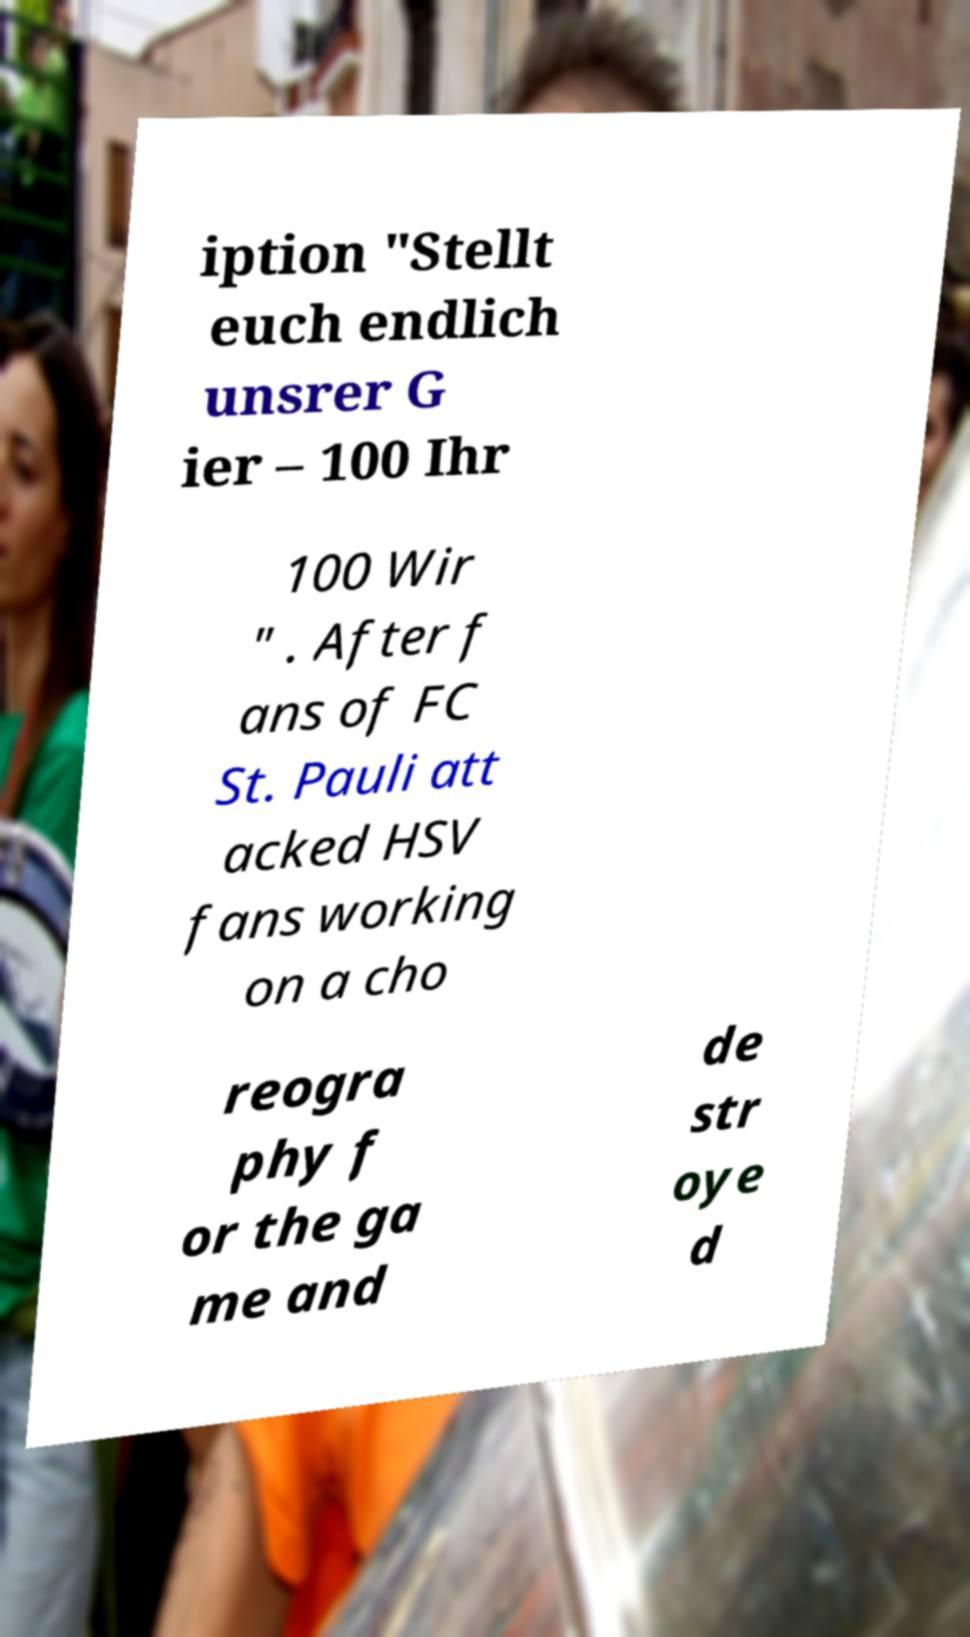I need the written content from this picture converted into text. Can you do that? iption "Stellt euch endlich unsrer G ier – 100 Ihr 100 Wir " . After f ans of FC St. Pauli att acked HSV fans working on a cho reogra phy f or the ga me and de str oye d 